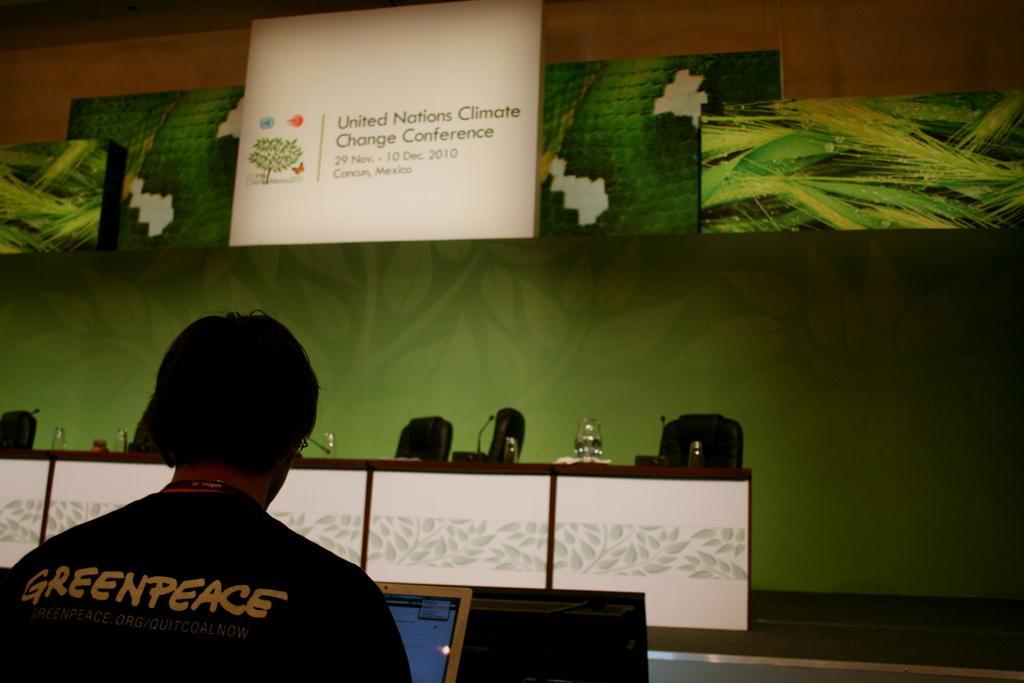How would you summarize this image in a sentence or two? In the picture we can see a man sitting on the chair and working in the system, he is wearing a black T-shirt written on it as black peace and in the background we can see a wall with some screen on it. 